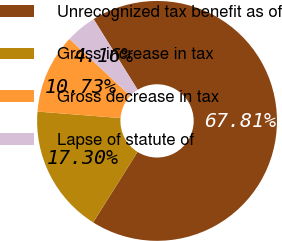<chart> <loc_0><loc_0><loc_500><loc_500><pie_chart><fcel>Unrecognized tax benefit as of<fcel>Gross increase in tax<fcel>Gross decrease in tax<fcel>Lapse of statute of<nl><fcel>67.8%<fcel>17.3%<fcel>10.73%<fcel>4.16%<nl></chart> 